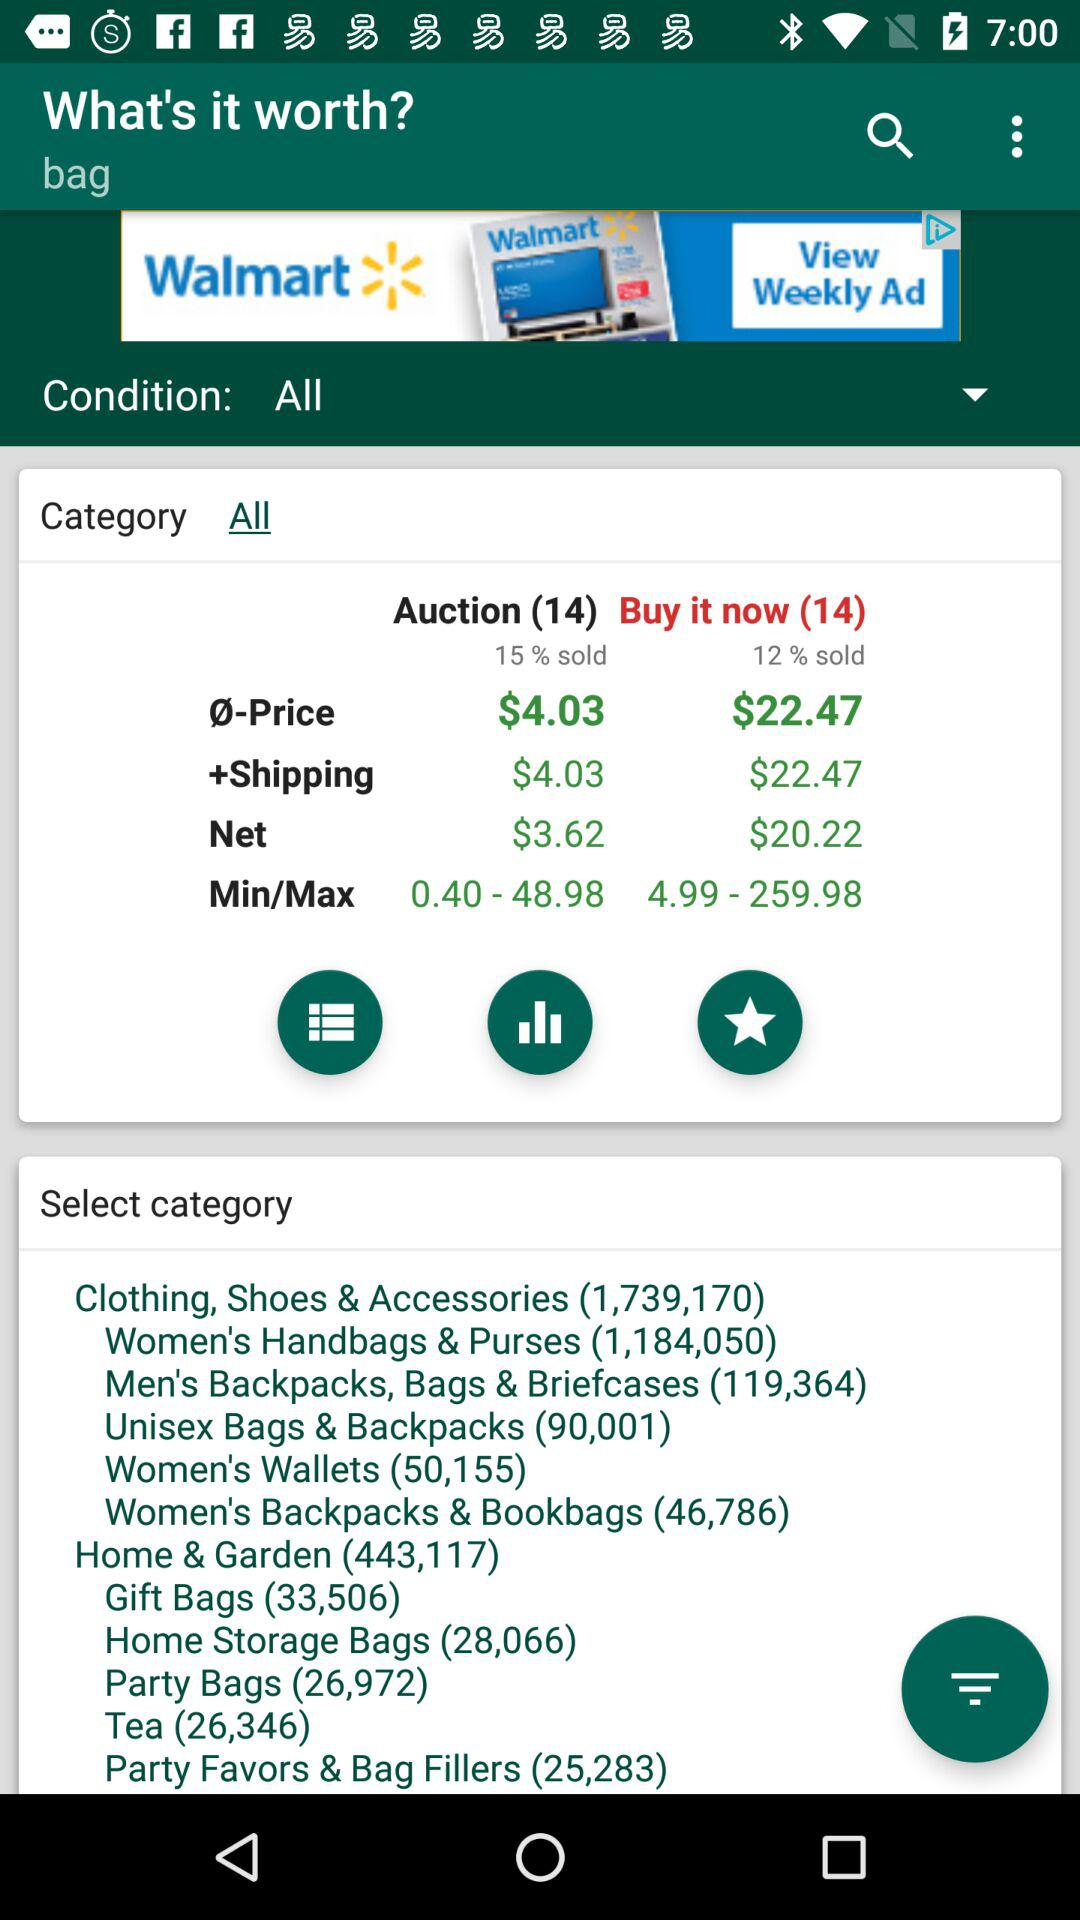Which tab is selected? The selected tab is "All". 